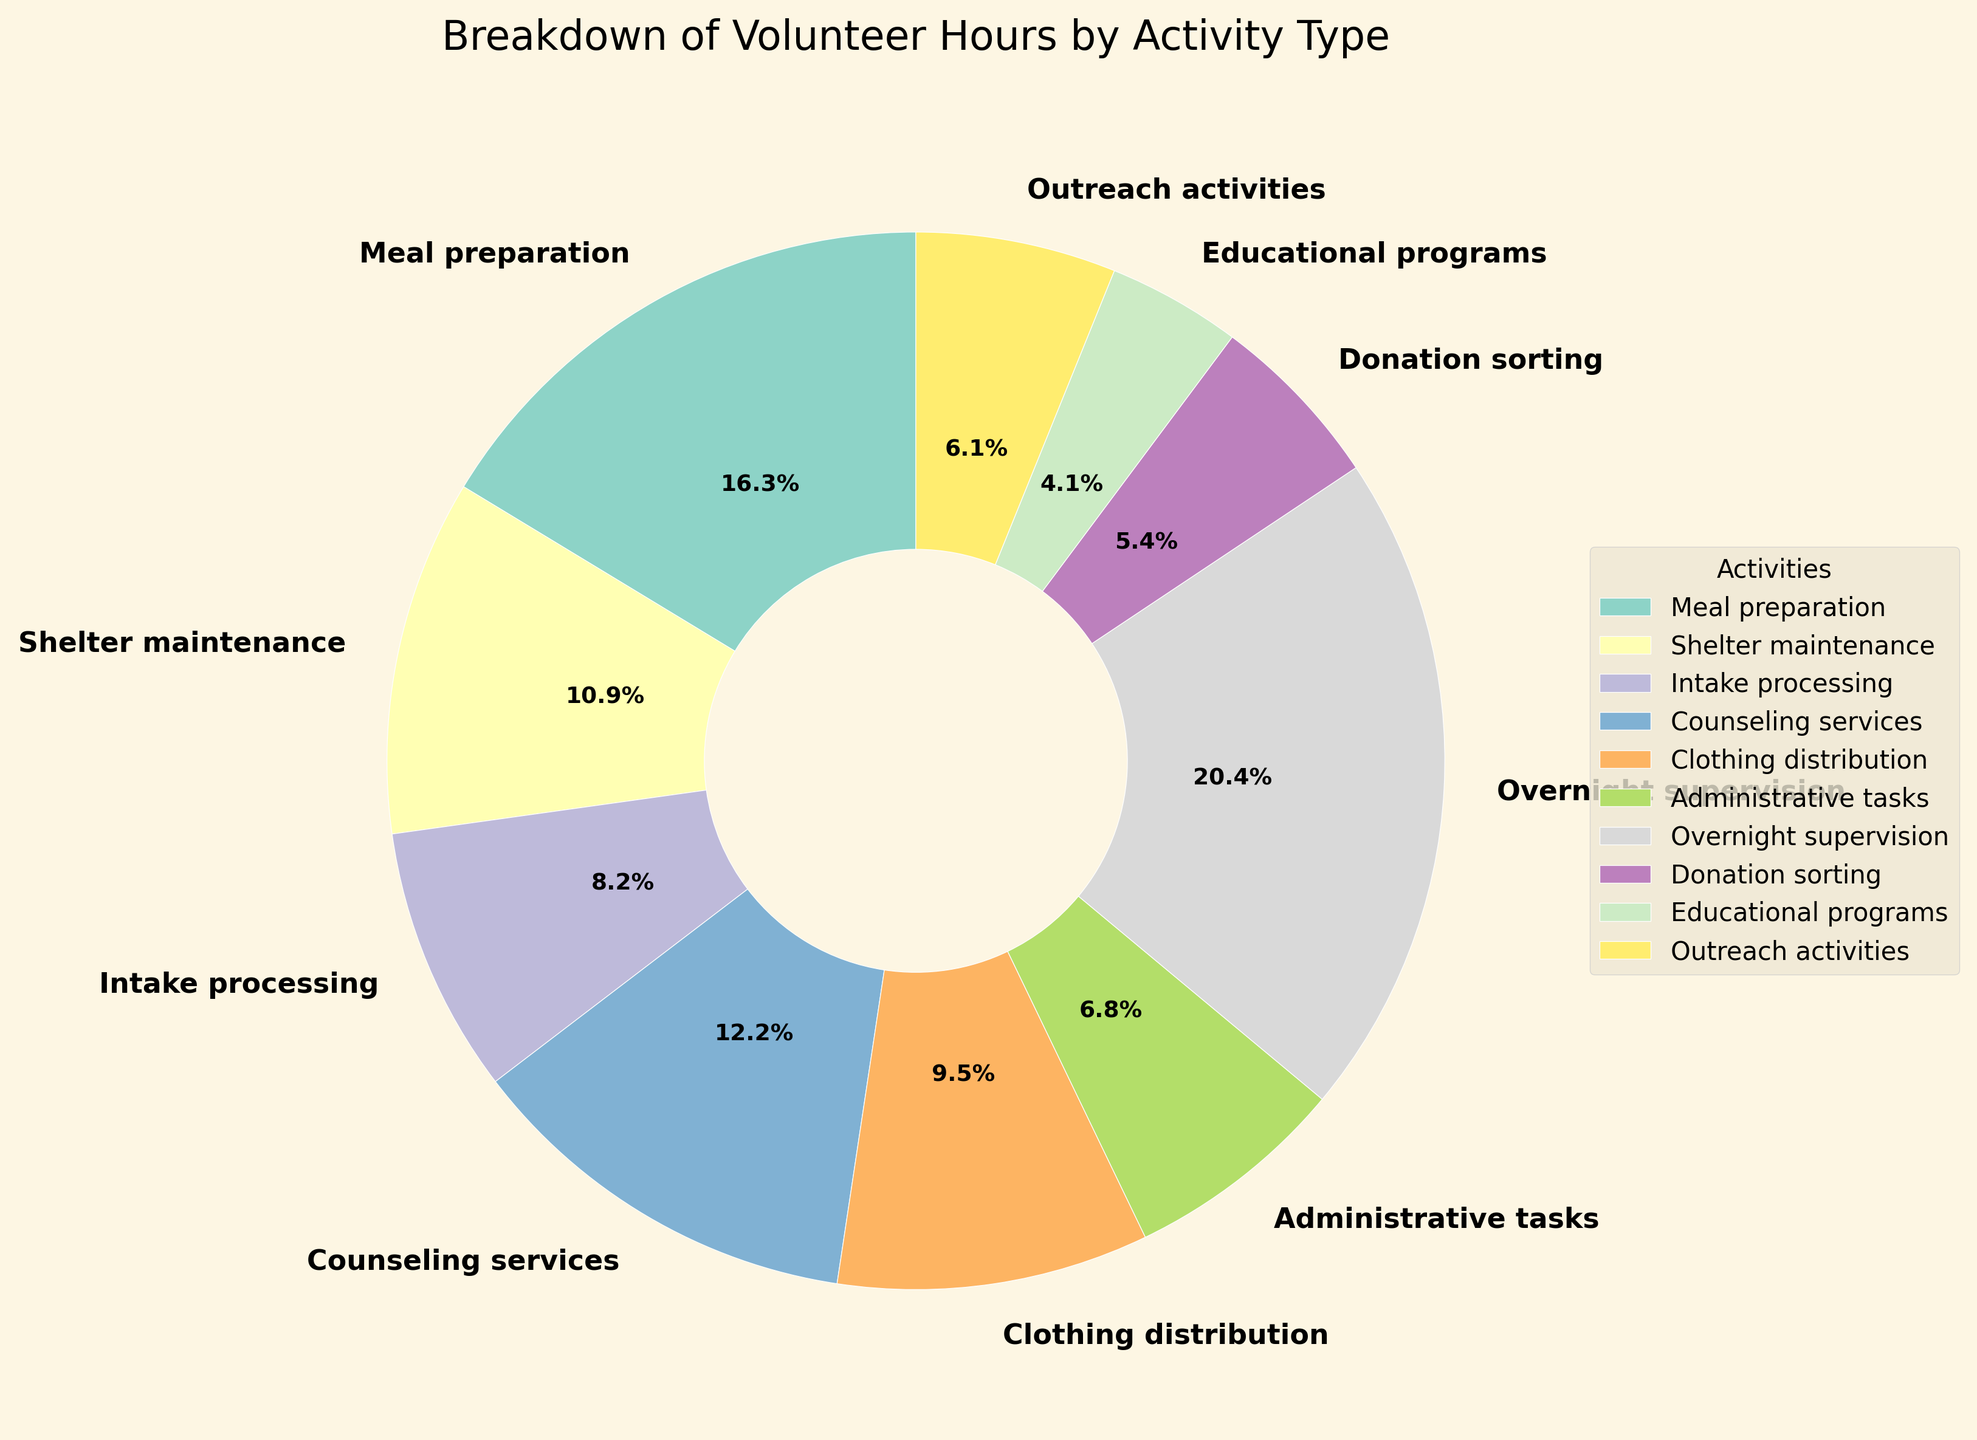What activity received the highest number of volunteer hours? By looking at the pie chart, the activity with the largest segment represents the highest number of volunteer hours.
Answer: Overnight supervision Which activities together account for at least 50% of the total volunteer hours? Considering the percentages from the chart, sum the percentages of activities until the total adds up to or exceeds 50%. Overnight supervision (23.6%) + Meal preparation (18.9%) = 42.5%, add Counseling services (14.2%) to reach 56.7%.
Answer: Overnight supervision, Meal preparation, and Counseling services How much more volunteer time was spent on Meal preparation than on Administrative tasks? Subtract the hours for Administrative tasks from the hours for Meal preparation: 120 hours (Meal preparation) - 50 hours (Administrative tasks) = 70 hours.
Answer: 70 hours What is the smallest segment in the pie chart and what percentage does it represent? The smallest segment visually is the smallest slice, which represents Educational programs. The percentage associated with it is shown on the segment.
Answer: Educational programs, 4.7% Which activity is the second largest in terms of volunteer hours, and how many hours were devoted to it? By observing the segments' sizes, the second-largest segment after Overnight supervision is Meal preparation. The number of hours for Meal preparation is indicated by the chart.
Answer: Meal preparation, 120 hours How many more hours were spent on Outreach activities and Clothing distribution combined than on Donation sorting? Add hours for Outreach activities and Clothing distribution and compare it to Donation sorting: (45 + 70) hours - 40 hours = 75 hours.
Answer: 75 hours What percentage of total volunteer hours were spent on Intake processing and Shelter maintenance combined? Calculate combined hours and divide them by the total, then multiply by 100 to get the percentage. (60 + 80) = 140 hours; Total hours = 735; (140 / 735) * 100 ≈ 19.0%.
Answer: 19.0% Which activity has a similar volunteer hour percentage to Clothing distribution, and what is that percentage? Visually identify a segment similar in size to Clothing distribution whose percentage is labeled on the chart. Administrative tasks has a similar size, both around 9.5% and 7.1%.
Answer: Administrative tasks, 7.1% How many hours in total were devoted to tasks related to direct client interaction (Intake processing, Counseling services, Educational programs, Outreach activities)? Sum the hours for all direct client interaction activities: 60 + 90 + 30 + 45 = 225 hours.
Answer: 225 hours Calculate the percentage of total hours for overnight supervision plus administrative tasks? Combine hours for overnight supervision and administrative tasks and divide by the total, then multiply by 100: (150 + 50) / 735 ≈ 27.2%
Answer: 27.2% 